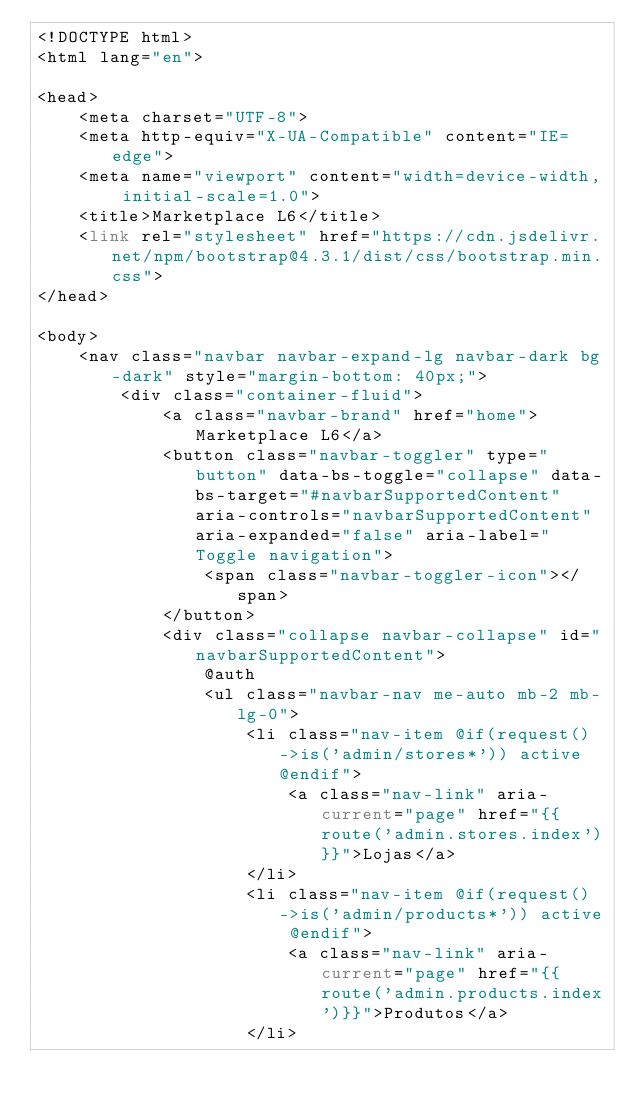<code> <loc_0><loc_0><loc_500><loc_500><_PHP_><!DOCTYPE html>
<html lang="en">

<head>
    <meta charset="UTF-8">
    <meta http-equiv="X-UA-Compatible" content="IE=edge">
    <meta name="viewport" content="width=device-width, initial-scale=1.0">
    <title>Marketplace L6</title>
    <link rel="stylesheet" href="https://cdn.jsdelivr.net/npm/bootstrap@4.3.1/dist/css/bootstrap.min.css">
</head>

<body>
    <nav class="navbar navbar-expand-lg navbar-dark bg-dark" style="margin-bottom: 40px;">
        <div class="container-fluid">
            <a class="navbar-brand" href="home">Marketplace L6</a>
            <button class="navbar-toggler" type="button" data-bs-toggle="collapse" data-bs-target="#navbarSupportedContent" aria-controls="navbarSupportedContent" aria-expanded="false" aria-label="Toggle navigation">
                <span class="navbar-toggler-icon"></span>
            </button>
            <div class="collapse navbar-collapse" id="navbarSupportedContent">
                @auth
                <ul class="navbar-nav me-auto mb-2 mb-lg-0">
                    <li class="nav-item @if(request()->is('admin/stores*')) active @endif">
                        <a class="nav-link" aria-current="page" href="{{route('admin.stores.index')}}">Lojas</a>
                    </li>
                    <li class="nav-item @if(request()->is('admin/products*')) active @endif">
                        <a class="nav-link" aria-current="page" href="{{route('admin.products.index')}}">Produtos</a>
                    </li></code> 